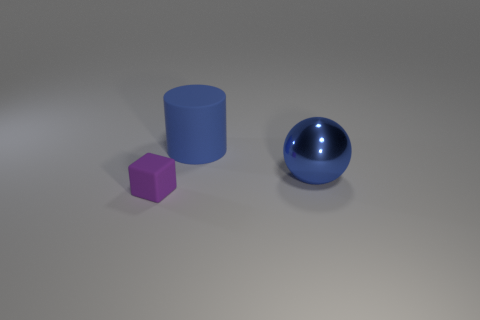Add 2 small purple blocks. How many objects exist? 5 Subtract all spheres. How many objects are left? 2 Subtract all red cylinders. Subtract all green blocks. How many cylinders are left? 1 Subtract all blue blocks. How many purple cylinders are left? 0 Subtract 1 blue cylinders. How many objects are left? 2 Subtract all purple cylinders. Subtract all blue objects. How many objects are left? 1 Add 1 big blue metallic things. How many big blue metallic things are left? 2 Add 1 blue cylinders. How many blue cylinders exist? 2 